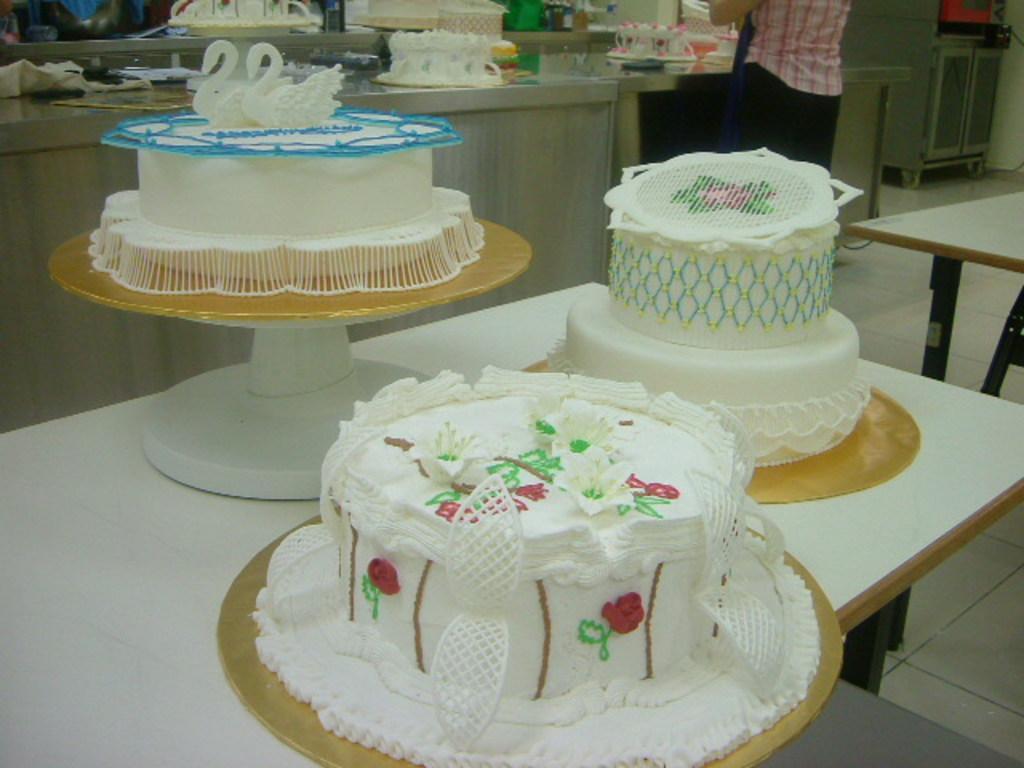How would you summarize this image in a sentence or two? In this picture there are three beautifully designed white cakes placed on top of a table. In the background we also observe few cakes which are in progress. 